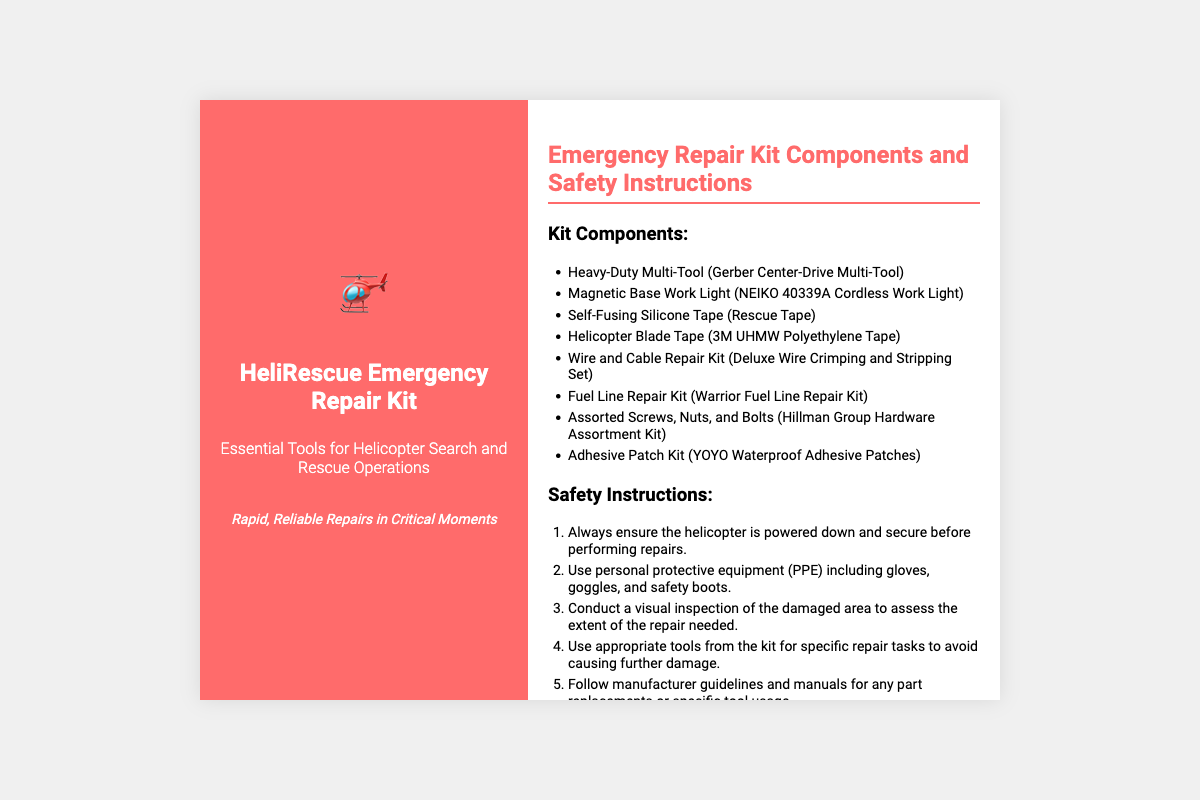what is the name of the emergency repair kit? The name of the kit is prominently displayed at the top of the front label.
Answer: HeliRescue Emergency Repair Kit how many components are listed in the kit? The total number of components can be counted in the components list section.
Answer: 8 what is the first component of the kit? The first component is mentioned at the beginning of the components list.
Answer: Heavy-Duty Multi-Tool (Gerber Center-Drive Multi-Tool) what safety instruction advises on personal protective equipment? The instruction regarding PPE is the second point in the safety instructions list.
Answer: Use personal protective equipment (PPE) including gloves, goggles, and safety boots what should be checked after completing repairs? The last instruction in the safety guidelines emphasizes checking a specific aspect after finishing repairs.
Answer: thorough checklist review what is the suggested product for helicopter blade tape? This question pertains to the specific component used for helicopter blade repair listed in the components.
Answer: 3M UHMW Polyethylene Tape which type of repair kit is included for fuel lines? The specific type of repair kit for fuel lines is mentioned in the components list.
Answer: Warrior Fuel Line Repair Kit what is indicated to be the purpose of the kit? The purpose is described in the subtitle of the front label.
Answer: Essential Tools for Helicopter Search and Rescue Operations 